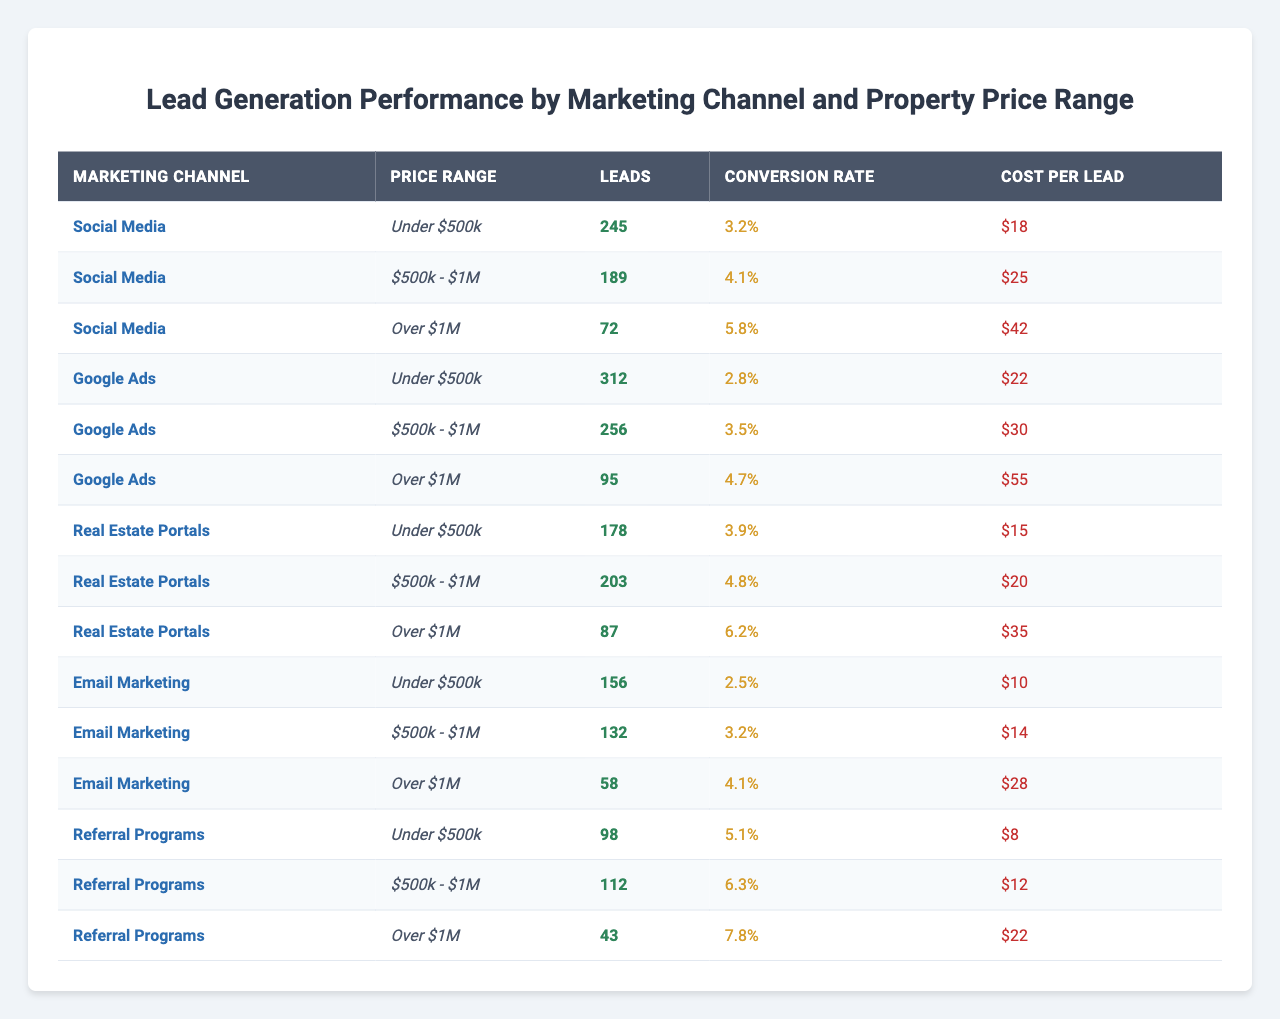What is the total number of leads generated through Google Ads for properties priced under $500k? According to the table, Google Ads generated 312 leads for properties priced under $500k.
Answer: 312 Which marketing channel had the highest conversion rate for properties priced over $1M? The highest conversion rate for properties over $1M is found in the Referral Programs, with a conversion rate of 7.8%.
Answer: 7.8% What is the average cost per lead across all channels for properties priced between $500k and $1M? The cost per lead for properties priced $500k - $1M is: Social Media: $25, Google Ads: $30, Real Estate Portals: $20, Email Marketing: $14, and Referral Programs: $12. The total cost per lead is $25 + $30 + $20 + $14 + $12 = $111. There are 5 channels, so the average cost per lead is $111 / 5 = $22.2.
Answer: $22.2 How many more leads did Google Ads generate than Real Estate Portals for properties priced under $500k? Google Ads generated 312 leads while Real Estate Portals generated 178 leads. The difference is 312 - 178 = 134.
Answer: 134 Is the cost per lead for Social Media higher than for Email Marketing for properties priced over $1M? The cost per lead for Social Media for properties over $1M is $42, while for Email Marketing it is $28. Since $42 is greater than $28, the statement is true.
Answer: Yes What is the total number of leads generated by all channels for properties priced under $500k? To find the total leads generated for properties under $500k, we sum the leads from each channel: 245 (Social Media) + 312 (Google Ads) + 178 (Real Estate Portals) + 156 (Email Marketing) + 98 (Referral Programs) = 1,067.
Answer: 1,067 Which marketing channel generated the least leads for properties priced between $500k and $1M? For the $500k - $1M price range, the leads generated are: 189 (Social Media), 256 (Google Ads), 203 (Real Estate Portals), 132 (Email Marketing), and 112 (Referral Programs). The least leads were generated by Email Marketing with 132 leads.
Answer: Email Marketing If we were to increase the leads from the Referral Programs by 10% for properties priced over $1M, how many leads would that be? The current leads from Referral Programs for properties over $1M is 43. An increase of 10% means we calculate 10% of 43: 0.10 * 43 = 4.3. Adding this to the original leads gives us 43 + 4.3 = 47.3, which we round down to 47 leads.
Answer: 47 What is the total conversion rate for all channels when considering properties priced under $500k? The conversion rates for properties priced under $500k are: Social Media: 3.2%, Google Ads: 2.8%, Real Estate Portals: 3.9%, Email Marketing: 2.5%, and Referral Programs: 5.1%. When calculating the sum: 3.2 + 2.8 + 3.9 + 2.5 + 5.1 = 17.5%. We divide by 5 for the average = 17.5 / 5 = 3.5%.
Answer: 3.5% Which price range has the highest cost per lead, and what is the amount? The cost per lead for properties over $1M is highest among all channels at $55 from Google Ads.
Answer: Over $1M, $55 